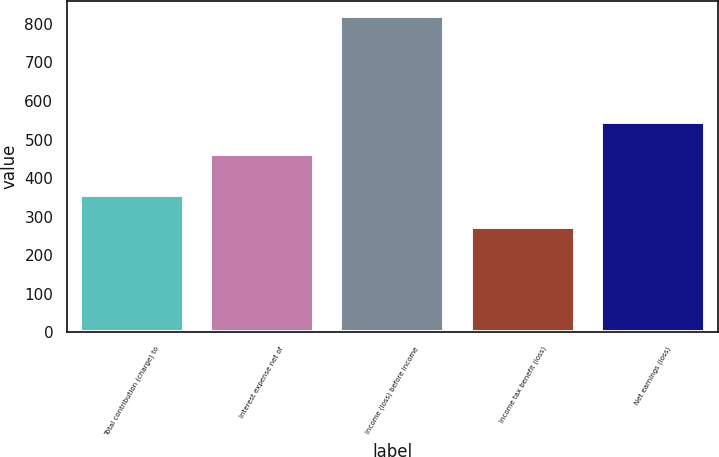<chart> <loc_0><loc_0><loc_500><loc_500><bar_chart><fcel>Total contribution (charge) to<fcel>Interest expense net of<fcel>Income (loss) before income<fcel>Income tax benefit (loss)<fcel>Net earnings (loss)<nl><fcel>357<fcel>462<fcel>819<fcel>274<fcel>545<nl></chart> 